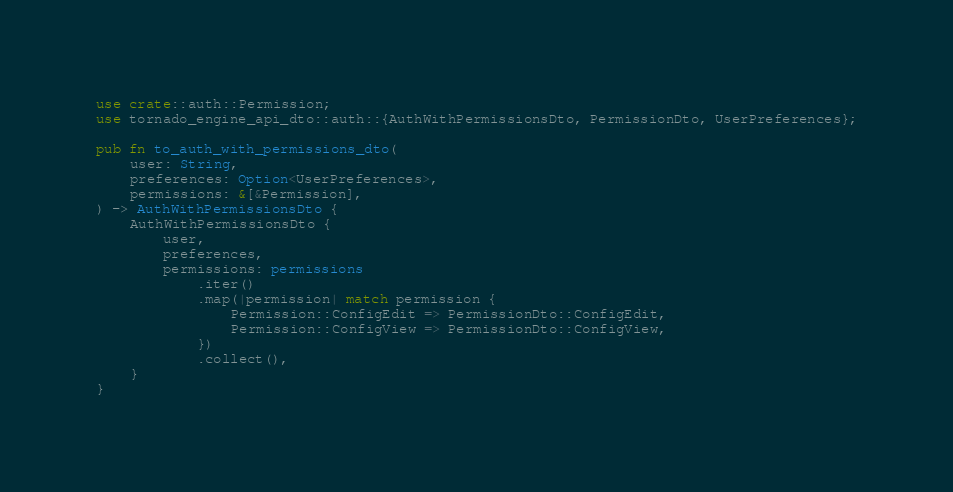<code> <loc_0><loc_0><loc_500><loc_500><_Rust_>use crate::auth::Permission;
use tornado_engine_api_dto::auth::{AuthWithPermissionsDto, PermissionDto, UserPreferences};

pub fn to_auth_with_permissions_dto(
    user: String,
    preferences: Option<UserPreferences>,
    permissions: &[&Permission],
) -> AuthWithPermissionsDto {
    AuthWithPermissionsDto {
        user,
        preferences,
        permissions: permissions
            .iter()
            .map(|permission| match permission {
                Permission::ConfigEdit => PermissionDto::ConfigEdit,
                Permission::ConfigView => PermissionDto::ConfigView,
            })
            .collect(),
    }
}
</code> 